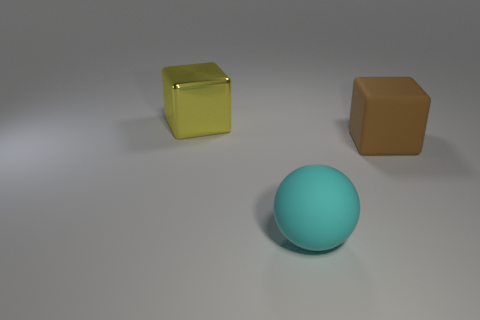Does the large cyan object have the same shape as the big yellow metal thing?
Provide a short and direct response. No. How many things are large cubes left of the cyan ball or big cyan metallic balls?
Make the answer very short. 1. What is the shape of the object that is right of the matte object in front of the block that is in front of the big metal cube?
Your answer should be compact. Cube. There is another object that is the same material as the big cyan thing; what is its shape?
Provide a succinct answer. Cube. How many things are either things in front of the big yellow thing or big things that are behind the brown object?
Offer a terse response. 3. There is a rubber object that is to the right of the rubber thing in front of the large brown matte thing; how many large brown rubber blocks are behind it?
Your response must be concise. 0. There is a cube that is left of the large cyan object; what is its size?
Ensure brevity in your answer.  Large. How many cyan things are the same size as the cyan sphere?
Your response must be concise. 0. How many things are either big cyan spheres or red metal balls?
Give a very brief answer. 1. There is a metallic thing that is the same size as the brown block; what is its shape?
Offer a very short reply. Cube. 